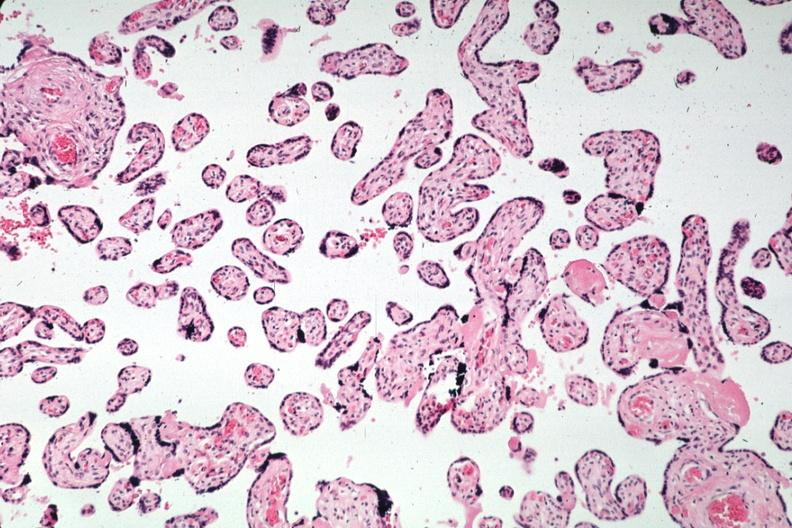s placenta present?
Answer the question using a single word or phrase. Yes 